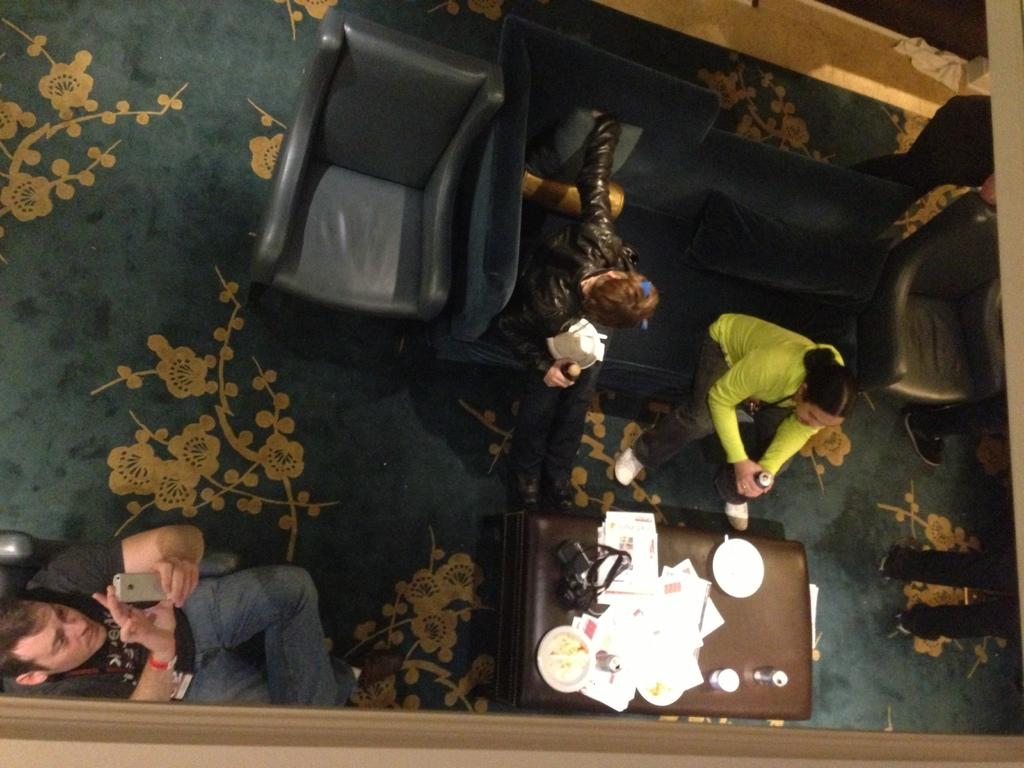How many people are in the image? There are three persons in the image. What are the persons doing in the image? The persons are sitting on a couch. What is located at the bottom of the image? There is a table at the bottom of the image. What can be found on the table? There are objects on the table. What type of loaf is being served at the harbor in the image? There is no harbor or loaf present in the image. What month is it in the image? The image does not provide any information about the month. 